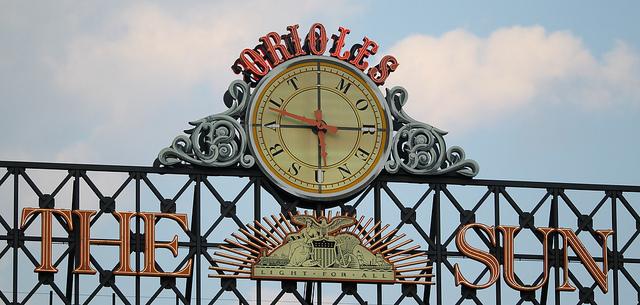What is written above the clock?
Concise answer only. Orioles. Are there numbers on the clock?
Quick response, please. No. What time is it?
Answer briefly. 5:48. 